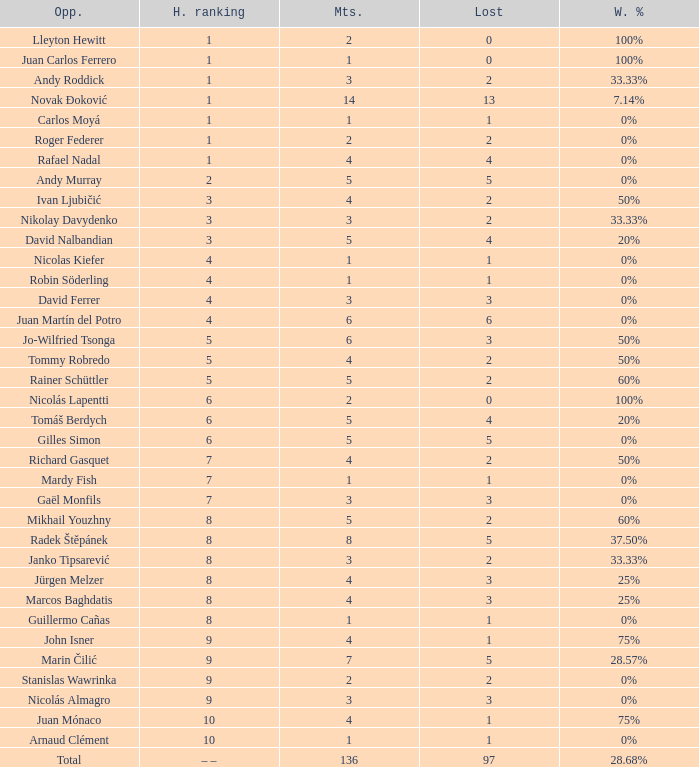What is the total number of Lost for the Highest Ranking of – –? 1.0. 